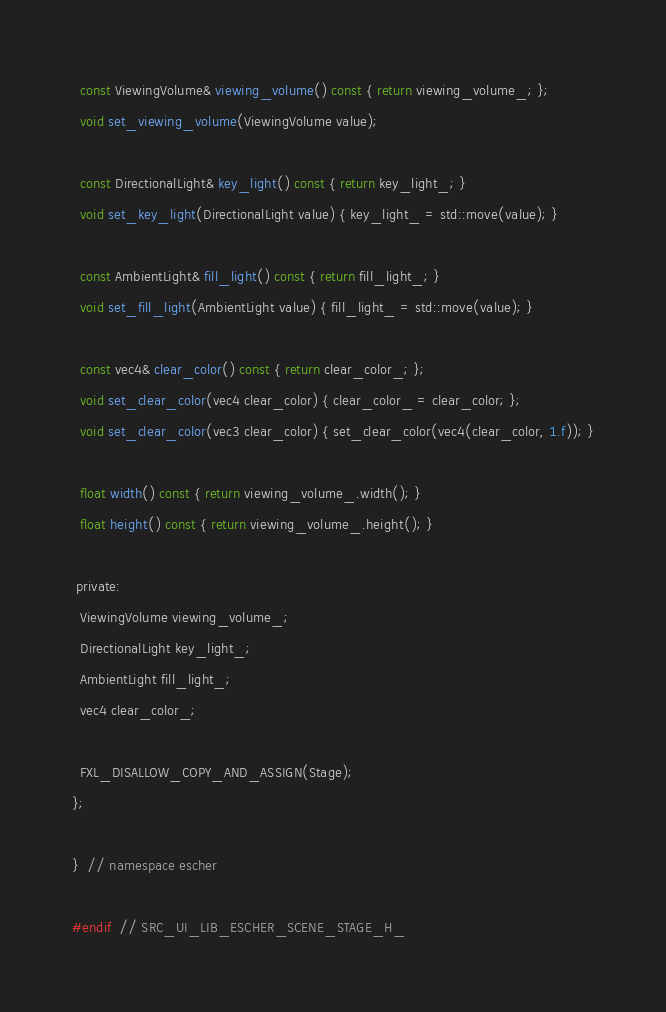<code> <loc_0><loc_0><loc_500><loc_500><_C_>
  const ViewingVolume& viewing_volume() const { return viewing_volume_; };
  void set_viewing_volume(ViewingVolume value);

  const DirectionalLight& key_light() const { return key_light_; }
  void set_key_light(DirectionalLight value) { key_light_ = std::move(value); }

  const AmbientLight& fill_light() const { return fill_light_; }
  void set_fill_light(AmbientLight value) { fill_light_ = std::move(value); }

  const vec4& clear_color() const { return clear_color_; };
  void set_clear_color(vec4 clear_color) { clear_color_ = clear_color; };
  void set_clear_color(vec3 clear_color) { set_clear_color(vec4(clear_color, 1.f)); }

  float width() const { return viewing_volume_.width(); }
  float height() const { return viewing_volume_.height(); }

 private:
  ViewingVolume viewing_volume_;
  DirectionalLight key_light_;
  AmbientLight fill_light_;
  vec4 clear_color_;

  FXL_DISALLOW_COPY_AND_ASSIGN(Stage);
};

}  // namespace escher

#endif  // SRC_UI_LIB_ESCHER_SCENE_STAGE_H_
</code> 